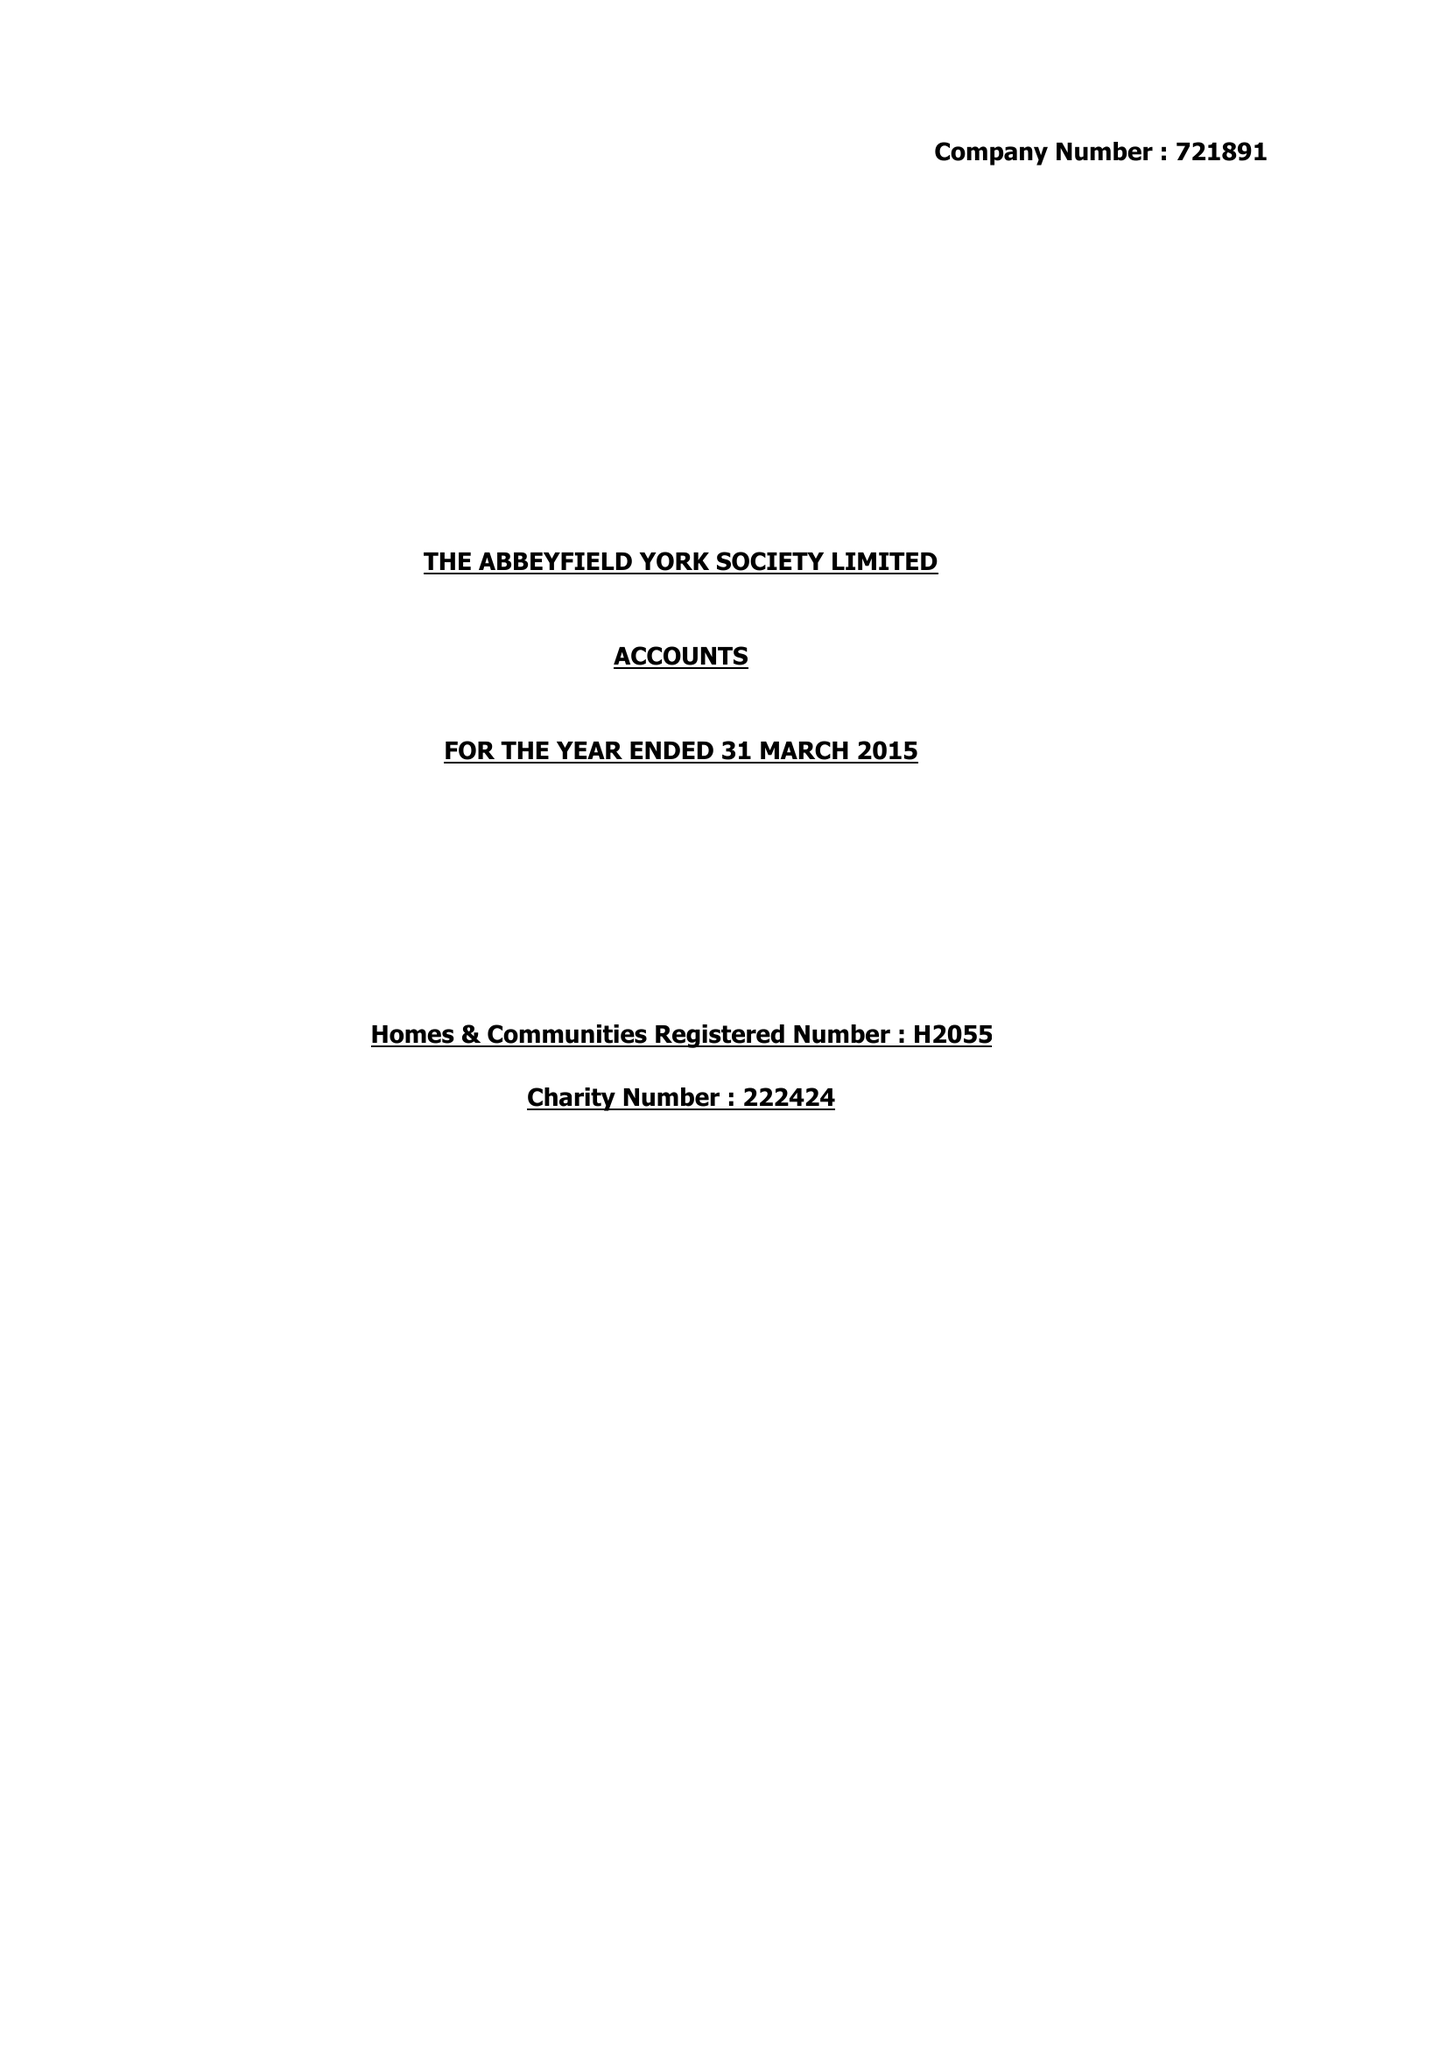What is the value for the address__postcode?
Answer the question using a single word or phrase. Y024 1LL 